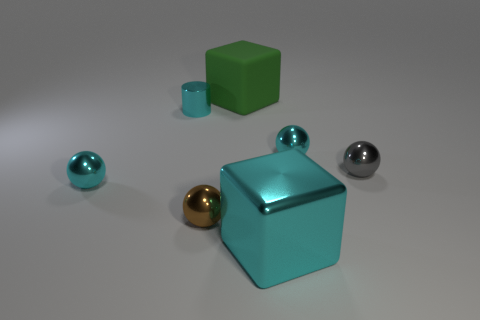Can you describe the lighting in the scene? The lighting in the scene appears to be diffused, with soft shadows indicating an overhead source, likely simulating ambient lighting in an indoor setting. 